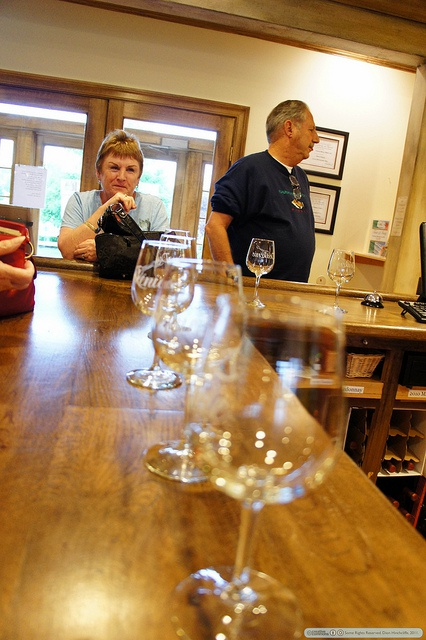Describe the objects in this image and their specific colors. I can see dining table in gray, olive, tan, and lightgray tones, wine glass in gray, olive, tan, and maroon tones, people in gray, black, brown, orange, and maroon tones, people in gray, black, brown, lightgray, and orange tones, and wine glass in gray, lightgray, darkgray, olive, and tan tones in this image. 